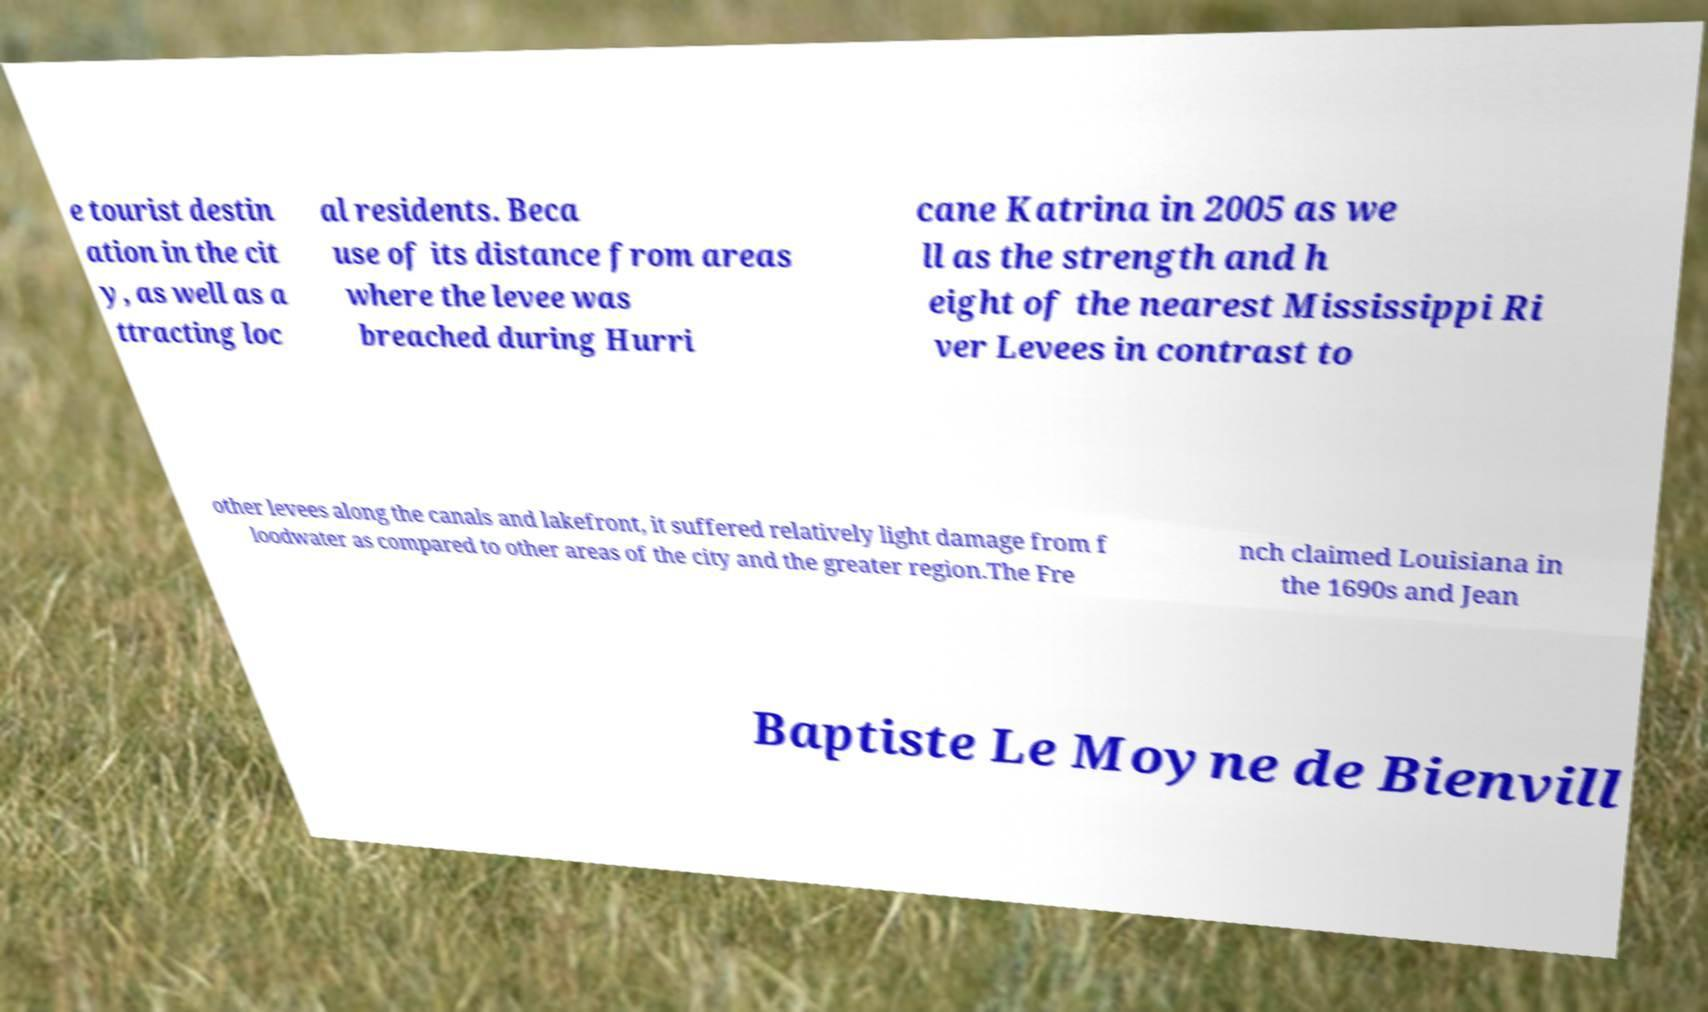Can you read and provide the text displayed in the image?This photo seems to have some interesting text. Can you extract and type it out for me? e tourist destin ation in the cit y, as well as a ttracting loc al residents. Beca use of its distance from areas where the levee was breached during Hurri cane Katrina in 2005 as we ll as the strength and h eight of the nearest Mississippi Ri ver Levees in contrast to other levees along the canals and lakefront, it suffered relatively light damage from f loodwater as compared to other areas of the city and the greater region.The Fre nch claimed Louisiana in the 1690s and Jean Baptiste Le Moyne de Bienvill 